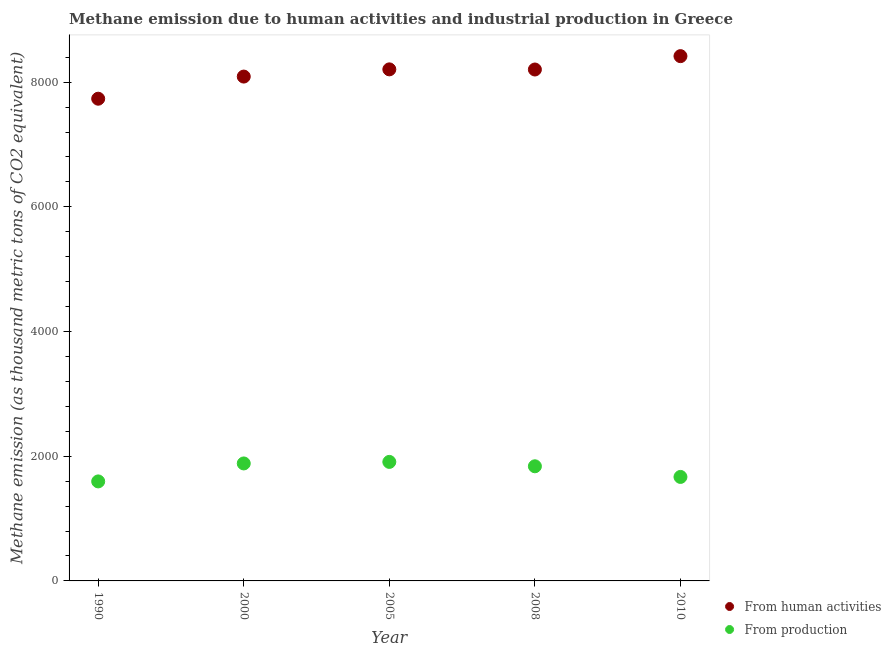How many different coloured dotlines are there?
Your answer should be very brief. 2. Is the number of dotlines equal to the number of legend labels?
Your answer should be compact. Yes. What is the amount of emissions generated from industries in 1990?
Give a very brief answer. 1596. Across all years, what is the maximum amount of emissions from human activities?
Offer a terse response. 8417. Across all years, what is the minimum amount of emissions generated from industries?
Your answer should be compact. 1596. In which year was the amount of emissions from human activities minimum?
Make the answer very short. 1990. What is the total amount of emissions generated from industries in the graph?
Provide a succinct answer. 8895.8. What is the difference between the amount of emissions generated from industries in 2005 and that in 2010?
Your answer should be compact. 241. What is the difference between the amount of emissions from human activities in 1990 and the amount of emissions generated from industries in 2000?
Your response must be concise. 5849.8. What is the average amount of emissions from human activities per year?
Your response must be concise. 8129.56. In the year 2008, what is the difference between the amount of emissions generated from industries and amount of emissions from human activities?
Provide a succinct answer. -6363.9. In how many years, is the amount of emissions from human activities greater than 7200 thousand metric tons?
Your answer should be compact. 5. What is the ratio of the amount of emissions generated from industries in 2008 to that in 2010?
Offer a very short reply. 1.1. Is the difference between the amount of emissions from human activities in 2005 and 2008 greater than the difference between the amount of emissions generated from industries in 2005 and 2008?
Provide a short and direct response. No. What is the difference between the highest and the second highest amount of emissions generated from industries?
Your answer should be very brief. 24.6. What is the difference between the highest and the lowest amount of emissions generated from industries?
Offer a terse response. 312.9. Does the amount of emissions from human activities monotonically increase over the years?
Provide a short and direct response. No. How many dotlines are there?
Offer a terse response. 2. How many years are there in the graph?
Keep it short and to the point. 5. Does the graph contain grids?
Your response must be concise. No. How many legend labels are there?
Offer a terse response. 2. How are the legend labels stacked?
Offer a very short reply. Vertical. What is the title of the graph?
Your answer should be very brief. Methane emission due to human activities and industrial production in Greece. What is the label or title of the X-axis?
Provide a short and direct response. Year. What is the label or title of the Y-axis?
Offer a terse response. Methane emission (as thousand metric tons of CO2 equivalent). What is the Methane emission (as thousand metric tons of CO2 equivalent) of From human activities in 1990?
Provide a succinct answer. 7734.1. What is the Methane emission (as thousand metric tons of CO2 equivalent) of From production in 1990?
Your answer should be compact. 1596. What is the Methane emission (as thousand metric tons of CO2 equivalent) in From human activities in 2000?
Provide a short and direct response. 8089.2. What is the Methane emission (as thousand metric tons of CO2 equivalent) of From production in 2000?
Offer a terse response. 1884.3. What is the Methane emission (as thousand metric tons of CO2 equivalent) of From human activities in 2005?
Provide a short and direct response. 8204.9. What is the Methane emission (as thousand metric tons of CO2 equivalent) of From production in 2005?
Your answer should be very brief. 1908.9. What is the Methane emission (as thousand metric tons of CO2 equivalent) of From human activities in 2008?
Your answer should be very brief. 8202.6. What is the Methane emission (as thousand metric tons of CO2 equivalent) in From production in 2008?
Your answer should be very brief. 1838.7. What is the Methane emission (as thousand metric tons of CO2 equivalent) in From human activities in 2010?
Offer a terse response. 8417. What is the Methane emission (as thousand metric tons of CO2 equivalent) in From production in 2010?
Ensure brevity in your answer.  1667.9. Across all years, what is the maximum Methane emission (as thousand metric tons of CO2 equivalent) in From human activities?
Offer a terse response. 8417. Across all years, what is the maximum Methane emission (as thousand metric tons of CO2 equivalent) in From production?
Provide a short and direct response. 1908.9. Across all years, what is the minimum Methane emission (as thousand metric tons of CO2 equivalent) of From human activities?
Your response must be concise. 7734.1. Across all years, what is the minimum Methane emission (as thousand metric tons of CO2 equivalent) in From production?
Provide a succinct answer. 1596. What is the total Methane emission (as thousand metric tons of CO2 equivalent) of From human activities in the graph?
Your answer should be very brief. 4.06e+04. What is the total Methane emission (as thousand metric tons of CO2 equivalent) in From production in the graph?
Your answer should be compact. 8895.8. What is the difference between the Methane emission (as thousand metric tons of CO2 equivalent) of From human activities in 1990 and that in 2000?
Provide a succinct answer. -355.1. What is the difference between the Methane emission (as thousand metric tons of CO2 equivalent) of From production in 1990 and that in 2000?
Ensure brevity in your answer.  -288.3. What is the difference between the Methane emission (as thousand metric tons of CO2 equivalent) in From human activities in 1990 and that in 2005?
Keep it short and to the point. -470.8. What is the difference between the Methane emission (as thousand metric tons of CO2 equivalent) in From production in 1990 and that in 2005?
Provide a succinct answer. -312.9. What is the difference between the Methane emission (as thousand metric tons of CO2 equivalent) in From human activities in 1990 and that in 2008?
Keep it short and to the point. -468.5. What is the difference between the Methane emission (as thousand metric tons of CO2 equivalent) in From production in 1990 and that in 2008?
Offer a very short reply. -242.7. What is the difference between the Methane emission (as thousand metric tons of CO2 equivalent) in From human activities in 1990 and that in 2010?
Offer a very short reply. -682.9. What is the difference between the Methane emission (as thousand metric tons of CO2 equivalent) of From production in 1990 and that in 2010?
Keep it short and to the point. -71.9. What is the difference between the Methane emission (as thousand metric tons of CO2 equivalent) of From human activities in 2000 and that in 2005?
Make the answer very short. -115.7. What is the difference between the Methane emission (as thousand metric tons of CO2 equivalent) in From production in 2000 and that in 2005?
Your response must be concise. -24.6. What is the difference between the Methane emission (as thousand metric tons of CO2 equivalent) of From human activities in 2000 and that in 2008?
Offer a terse response. -113.4. What is the difference between the Methane emission (as thousand metric tons of CO2 equivalent) of From production in 2000 and that in 2008?
Your answer should be very brief. 45.6. What is the difference between the Methane emission (as thousand metric tons of CO2 equivalent) of From human activities in 2000 and that in 2010?
Your answer should be very brief. -327.8. What is the difference between the Methane emission (as thousand metric tons of CO2 equivalent) of From production in 2000 and that in 2010?
Your response must be concise. 216.4. What is the difference between the Methane emission (as thousand metric tons of CO2 equivalent) of From production in 2005 and that in 2008?
Your answer should be very brief. 70.2. What is the difference between the Methane emission (as thousand metric tons of CO2 equivalent) of From human activities in 2005 and that in 2010?
Give a very brief answer. -212.1. What is the difference between the Methane emission (as thousand metric tons of CO2 equivalent) of From production in 2005 and that in 2010?
Your response must be concise. 241. What is the difference between the Methane emission (as thousand metric tons of CO2 equivalent) in From human activities in 2008 and that in 2010?
Give a very brief answer. -214.4. What is the difference between the Methane emission (as thousand metric tons of CO2 equivalent) in From production in 2008 and that in 2010?
Make the answer very short. 170.8. What is the difference between the Methane emission (as thousand metric tons of CO2 equivalent) of From human activities in 1990 and the Methane emission (as thousand metric tons of CO2 equivalent) of From production in 2000?
Offer a terse response. 5849.8. What is the difference between the Methane emission (as thousand metric tons of CO2 equivalent) in From human activities in 1990 and the Methane emission (as thousand metric tons of CO2 equivalent) in From production in 2005?
Provide a short and direct response. 5825.2. What is the difference between the Methane emission (as thousand metric tons of CO2 equivalent) of From human activities in 1990 and the Methane emission (as thousand metric tons of CO2 equivalent) of From production in 2008?
Your response must be concise. 5895.4. What is the difference between the Methane emission (as thousand metric tons of CO2 equivalent) in From human activities in 1990 and the Methane emission (as thousand metric tons of CO2 equivalent) in From production in 2010?
Your response must be concise. 6066.2. What is the difference between the Methane emission (as thousand metric tons of CO2 equivalent) of From human activities in 2000 and the Methane emission (as thousand metric tons of CO2 equivalent) of From production in 2005?
Your answer should be compact. 6180.3. What is the difference between the Methane emission (as thousand metric tons of CO2 equivalent) of From human activities in 2000 and the Methane emission (as thousand metric tons of CO2 equivalent) of From production in 2008?
Provide a short and direct response. 6250.5. What is the difference between the Methane emission (as thousand metric tons of CO2 equivalent) of From human activities in 2000 and the Methane emission (as thousand metric tons of CO2 equivalent) of From production in 2010?
Make the answer very short. 6421.3. What is the difference between the Methane emission (as thousand metric tons of CO2 equivalent) in From human activities in 2005 and the Methane emission (as thousand metric tons of CO2 equivalent) in From production in 2008?
Offer a very short reply. 6366.2. What is the difference between the Methane emission (as thousand metric tons of CO2 equivalent) in From human activities in 2005 and the Methane emission (as thousand metric tons of CO2 equivalent) in From production in 2010?
Ensure brevity in your answer.  6537. What is the difference between the Methane emission (as thousand metric tons of CO2 equivalent) of From human activities in 2008 and the Methane emission (as thousand metric tons of CO2 equivalent) of From production in 2010?
Your answer should be compact. 6534.7. What is the average Methane emission (as thousand metric tons of CO2 equivalent) in From human activities per year?
Your answer should be very brief. 8129.56. What is the average Methane emission (as thousand metric tons of CO2 equivalent) in From production per year?
Keep it short and to the point. 1779.16. In the year 1990, what is the difference between the Methane emission (as thousand metric tons of CO2 equivalent) of From human activities and Methane emission (as thousand metric tons of CO2 equivalent) of From production?
Ensure brevity in your answer.  6138.1. In the year 2000, what is the difference between the Methane emission (as thousand metric tons of CO2 equivalent) in From human activities and Methane emission (as thousand metric tons of CO2 equivalent) in From production?
Your response must be concise. 6204.9. In the year 2005, what is the difference between the Methane emission (as thousand metric tons of CO2 equivalent) of From human activities and Methane emission (as thousand metric tons of CO2 equivalent) of From production?
Provide a short and direct response. 6296. In the year 2008, what is the difference between the Methane emission (as thousand metric tons of CO2 equivalent) in From human activities and Methane emission (as thousand metric tons of CO2 equivalent) in From production?
Give a very brief answer. 6363.9. In the year 2010, what is the difference between the Methane emission (as thousand metric tons of CO2 equivalent) of From human activities and Methane emission (as thousand metric tons of CO2 equivalent) of From production?
Make the answer very short. 6749.1. What is the ratio of the Methane emission (as thousand metric tons of CO2 equivalent) of From human activities in 1990 to that in 2000?
Offer a very short reply. 0.96. What is the ratio of the Methane emission (as thousand metric tons of CO2 equivalent) of From production in 1990 to that in 2000?
Provide a succinct answer. 0.85. What is the ratio of the Methane emission (as thousand metric tons of CO2 equivalent) of From human activities in 1990 to that in 2005?
Your response must be concise. 0.94. What is the ratio of the Methane emission (as thousand metric tons of CO2 equivalent) in From production in 1990 to that in 2005?
Ensure brevity in your answer.  0.84. What is the ratio of the Methane emission (as thousand metric tons of CO2 equivalent) in From human activities in 1990 to that in 2008?
Give a very brief answer. 0.94. What is the ratio of the Methane emission (as thousand metric tons of CO2 equivalent) of From production in 1990 to that in 2008?
Ensure brevity in your answer.  0.87. What is the ratio of the Methane emission (as thousand metric tons of CO2 equivalent) in From human activities in 1990 to that in 2010?
Ensure brevity in your answer.  0.92. What is the ratio of the Methane emission (as thousand metric tons of CO2 equivalent) in From production in 1990 to that in 2010?
Ensure brevity in your answer.  0.96. What is the ratio of the Methane emission (as thousand metric tons of CO2 equivalent) in From human activities in 2000 to that in 2005?
Offer a very short reply. 0.99. What is the ratio of the Methane emission (as thousand metric tons of CO2 equivalent) in From production in 2000 to that in 2005?
Your response must be concise. 0.99. What is the ratio of the Methane emission (as thousand metric tons of CO2 equivalent) of From human activities in 2000 to that in 2008?
Provide a succinct answer. 0.99. What is the ratio of the Methane emission (as thousand metric tons of CO2 equivalent) of From production in 2000 to that in 2008?
Your response must be concise. 1.02. What is the ratio of the Methane emission (as thousand metric tons of CO2 equivalent) of From human activities in 2000 to that in 2010?
Provide a succinct answer. 0.96. What is the ratio of the Methane emission (as thousand metric tons of CO2 equivalent) in From production in 2000 to that in 2010?
Your answer should be compact. 1.13. What is the ratio of the Methane emission (as thousand metric tons of CO2 equivalent) in From production in 2005 to that in 2008?
Make the answer very short. 1.04. What is the ratio of the Methane emission (as thousand metric tons of CO2 equivalent) in From human activities in 2005 to that in 2010?
Provide a short and direct response. 0.97. What is the ratio of the Methane emission (as thousand metric tons of CO2 equivalent) of From production in 2005 to that in 2010?
Keep it short and to the point. 1.14. What is the ratio of the Methane emission (as thousand metric tons of CO2 equivalent) of From human activities in 2008 to that in 2010?
Your response must be concise. 0.97. What is the ratio of the Methane emission (as thousand metric tons of CO2 equivalent) in From production in 2008 to that in 2010?
Provide a short and direct response. 1.1. What is the difference between the highest and the second highest Methane emission (as thousand metric tons of CO2 equivalent) in From human activities?
Keep it short and to the point. 212.1. What is the difference between the highest and the second highest Methane emission (as thousand metric tons of CO2 equivalent) of From production?
Offer a terse response. 24.6. What is the difference between the highest and the lowest Methane emission (as thousand metric tons of CO2 equivalent) of From human activities?
Your answer should be very brief. 682.9. What is the difference between the highest and the lowest Methane emission (as thousand metric tons of CO2 equivalent) in From production?
Provide a succinct answer. 312.9. 